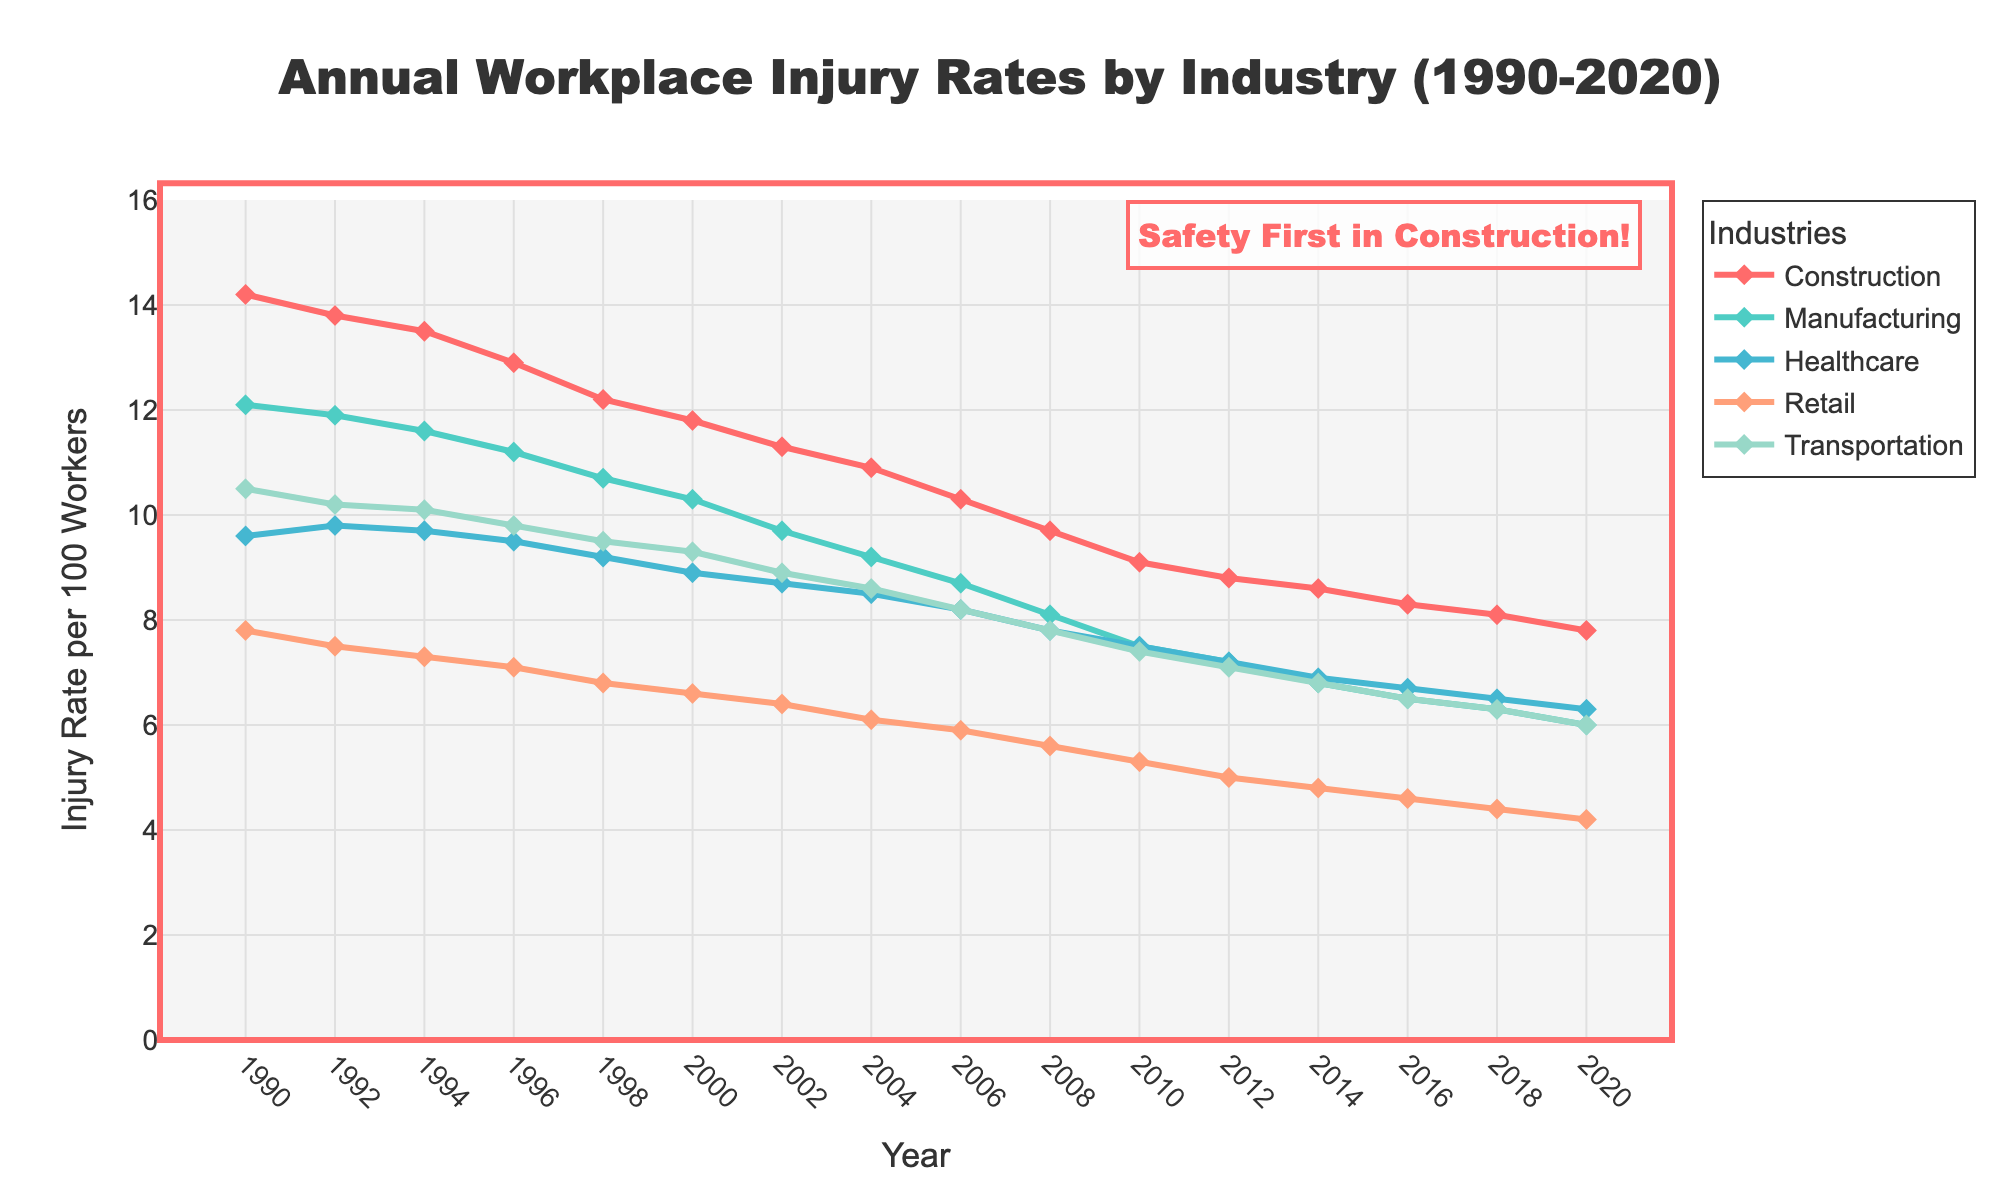What is the trend of injury rates in the construction industry from 1990 to 2020? To identify the trend, observe the line for the construction industry. The line shows a general decline in injury rates over time. Specifically, it starts at 14.2 in 1990 and drops to 7.8 in 2020.
Answer: Decreasing Which industry had the highest injury rate in 1998? To find the industry with the highest injury rate in 1998, compare the heights of all lines at that year. The construction industry line is the highest, marking an injury rate of 12.2.
Answer: Construction By how much did the injury rate in manufacturing change from 1990 to 2020? To find the change, subtract the injury rate in 2020 from that in 1990 for the manufacturing industry. The rate in 1990 was 12.1, and in 2020 it was 6.0. The change is 12.1 - 6.0 = 6.1.
Answer: 6.1 Which two industries had a similar injury rate in 2020? Identify the lines that are close to each other in 2020 on the y-axis. The retail and transportation lines are near each other with injury rates of 4.2 and 6.0, respectively.
Answer: Retail, Transportation What is the average injury rate of the construction industry over the entire period? Calculate the average by summing all injury rates for construction and dividing by the number of years. Sum = 14.2 + 13.8 + 13.5 + 12.9 + 12.2 + 11.8 + 11.3 + 10.9 + 10.3 + 9.7 + 9.1 + 8.8 + 8.6 + 8.3 + 8.1 + 7.8 = 180.3, Average = 180.3/16 = 11.27
Answer: 11.27 How did the injury rates in healthcare and retail industries compare in 2004? Compare the heights of the healthcare and retail industry lines in 2004. Healthcare is at 8.5, while retail is at 6.1.
Answer: Healthcare > Retail What is the difference between the highest injury rate and the lowest injury rate across all industries in 2010? Identify the highest and lowest points in 2010. The highest is construction at 9.1, and the lowest is retail at 5.3. The difference is 9.1 - 5.3 = 3.8.
Answer: 3.8 Which industry showed the most significant decrease in injury rates over the entire period? To determine the most significant decrease, subtract the 2020 rate from the 1990 rate for all industries, then find the highest decrement. Construction: 14.2-7.8=6.4, Manufacturing: 12.1-6.0=6.1, Healthcare: 9.6-6.3=3.3, Retail: 7.8-4.2=3.6, Transportation: 10.5-6.0=4.5. Thus, construction has the biggest decrease of 6.4.
Answer: Construction What is the combined injury rate for healthcare and retail in 2014? Add the injury rates for healthcare and retail in 2014. Healthcare: 6.9, Retail: 4.8. Combined = 6.9 + 4.8 = 11.7.
Answer: 11.7 Which industry has consistently been the lowest in injury rates since 1990? Identify the industry whose line is consistently lower than others through the period. The retail industry's line is consistently lower than the others from 1990 to 2020.
Answer: Retail 